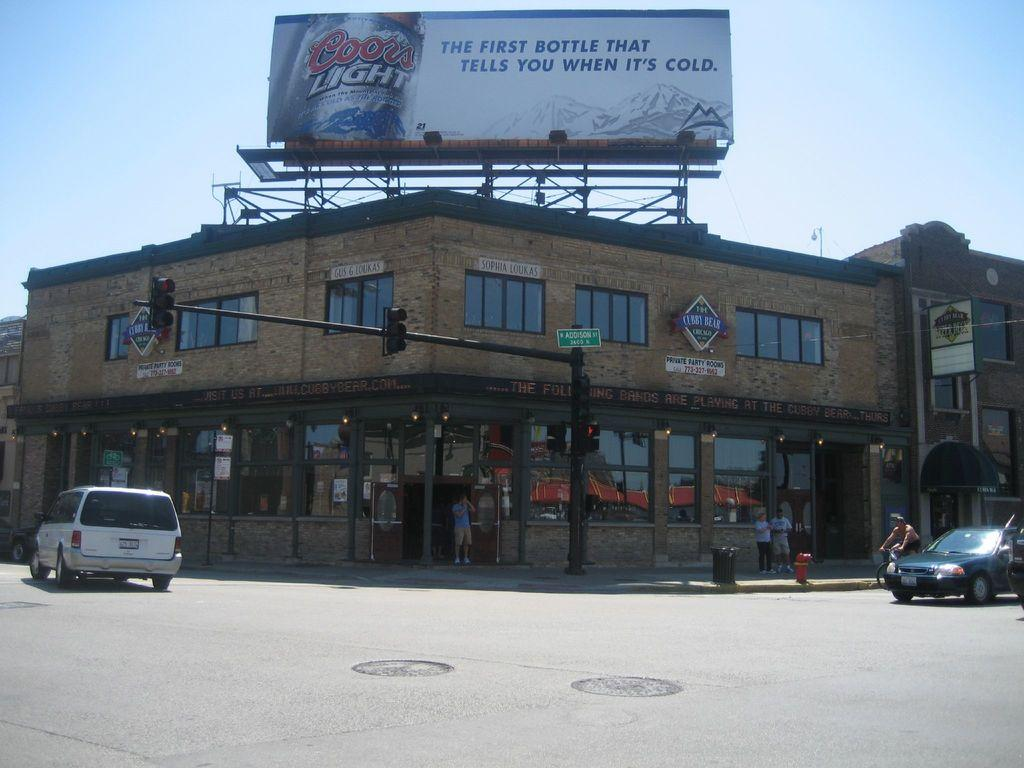Provide a one-sentence caption for the provided image. a building with a Coors Light billboard above it. 